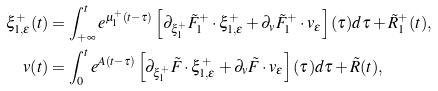Convert formula to latex. <formula><loc_0><loc_0><loc_500><loc_500>\xi ^ { + } _ { 1 , \epsilon } ( t ) & = \int ^ { t } _ { + \infty } e ^ { \mu ^ { + } _ { 1 } ( t - \tau ) } \left [ \partial _ { \xi ^ { + } _ { 1 } } \tilde { F } ^ { + } _ { 1 } \cdot \xi ^ { + } _ { 1 , \epsilon } + \partial _ { v } \tilde { F } ^ { + } _ { 1 } \cdot v _ { \epsilon } \right ] ( \tau ) d \tau + \tilde { R } ^ { + } _ { 1 } ( t ) , \\ v ( t ) & = \int ^ { t } _ { 0 } e ^ { A ( t - \tau ) } \left [ \partial _ { \xi ^ { + } _ { 1 } } \tilde { F } \cdot \xi ^ { + } _ { 1 , \epsilon } + \partial _ { v } \tilde { F } \cdot v _ { \epsilon } \right ] ( \tau ) d \tau + \tilde { R } ( t ) ,</formula> 